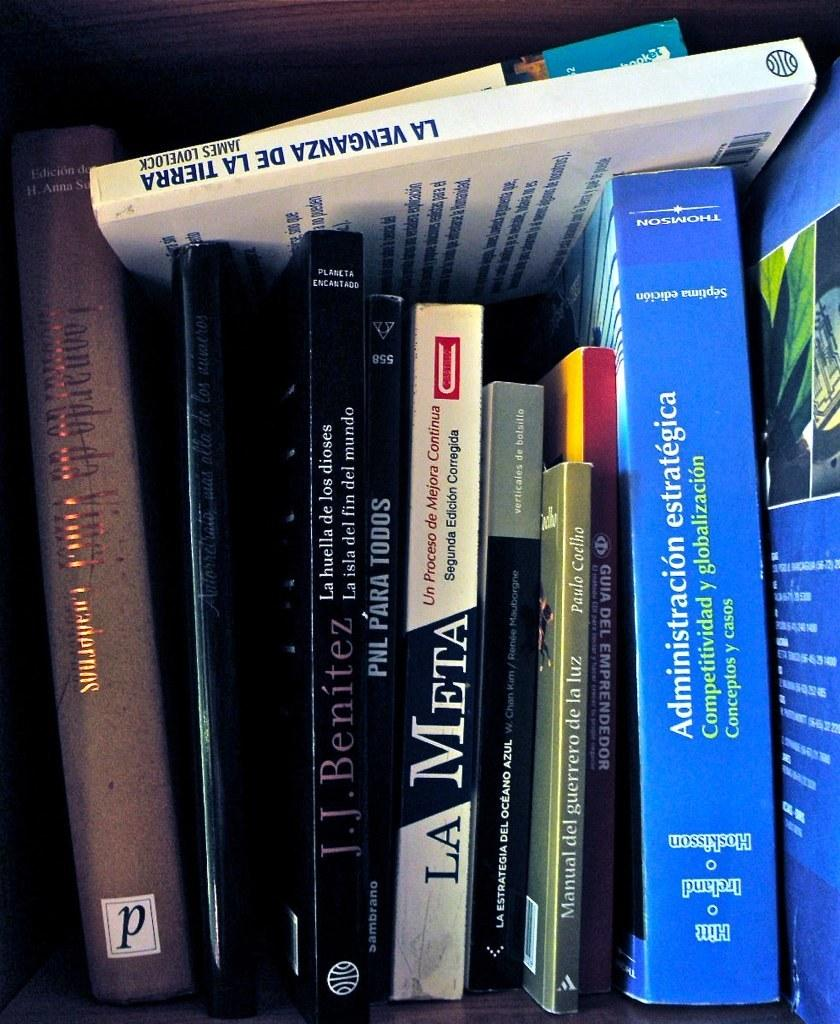<image>
Create a compact narrative representing the image presented. A stack of books in different languages, one being La Meta 